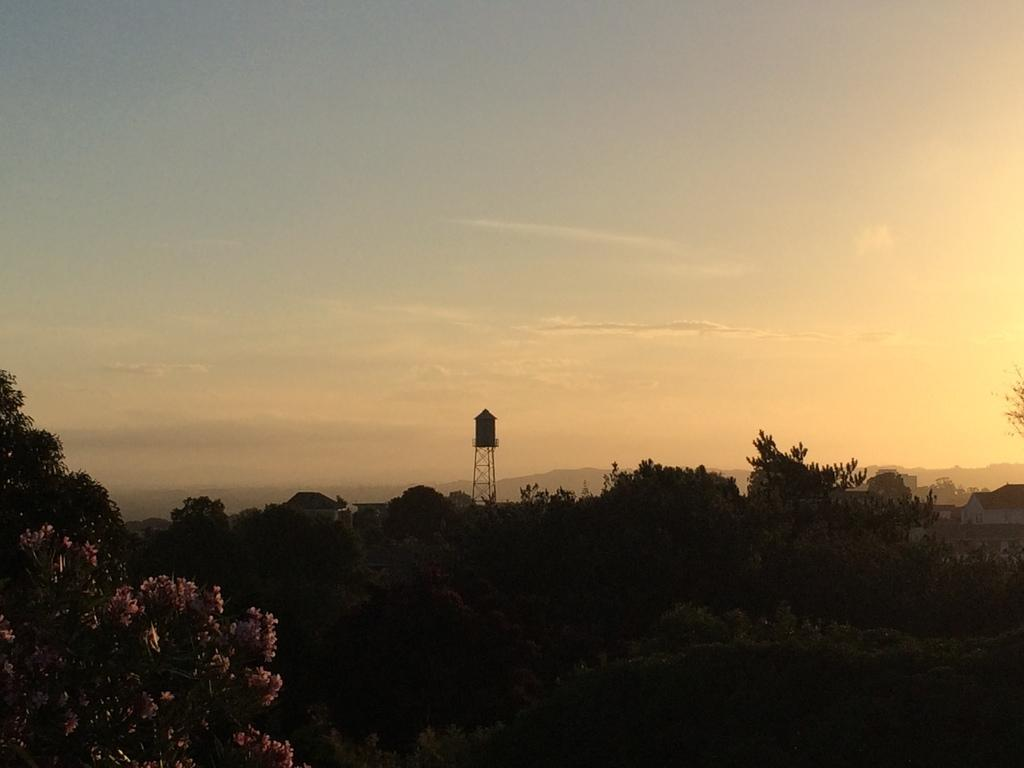What is the overall lighting condition of the image? The image is dark. What type of natural elements can be seen in the image? There are trees in the image. What structure can be seen in the background of the image? There is a tower visible in the background of the image. What else is visible in the background of the image? The sky is visible in the background of the image, and clouds are present in the sky. Can you tell me how many people are asking for help in the image? There is no indication of people asking for help in the image; it primarily features trees, a tower, and a dark sky with clouds. 